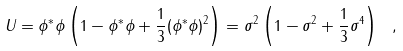Convert formula to latex. <formula><loc_0><loc_0><loc_500><loc_500>U = \phi ^ { \ast } \phi \left ( 1 - \phi ^ { \ast } \phi + \frac { 1 } { 3 } ( \phi ^ { \ast } \phi ) ^ { 2 } \right ) = \sigma ^ { 2 } \left ( 1 - \sigma ^ { 2 } + \frac { 1 } { 3 } \sigma ^ { 4 } \right ) \ ,</formula> 